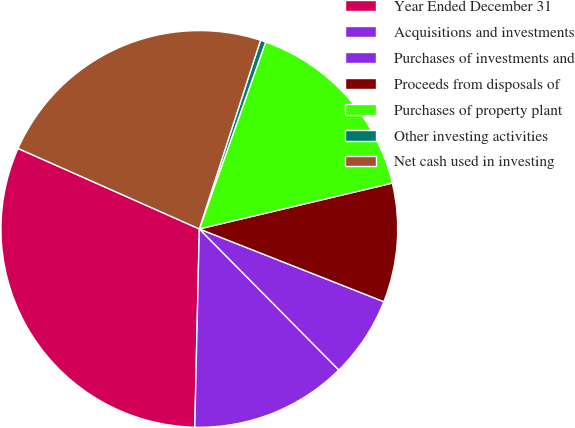<chart> <loc_0><loc_0><loc_500><loc_500><pie_chart><fcel>Year Ended December 31<fcel>Acquisitions and investments<fcel>Purchases of investments and<fcel>Proceeds from disposals of<fcel>Purchases of property plant<fcel>Other investing activities<fcel>Net cash used in investing<nl><fcel>31.29%<fcel>12.78%<fcel>6.61%<fcel>9.69%<fcel>15.86%<fcel>0.44%<fcel>23.34%<nl></chart> 